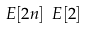<formula> <loc_0><loc_0><loc_500><loc_500>E [ 2 n ] \ E [ 2 ]</formula> 